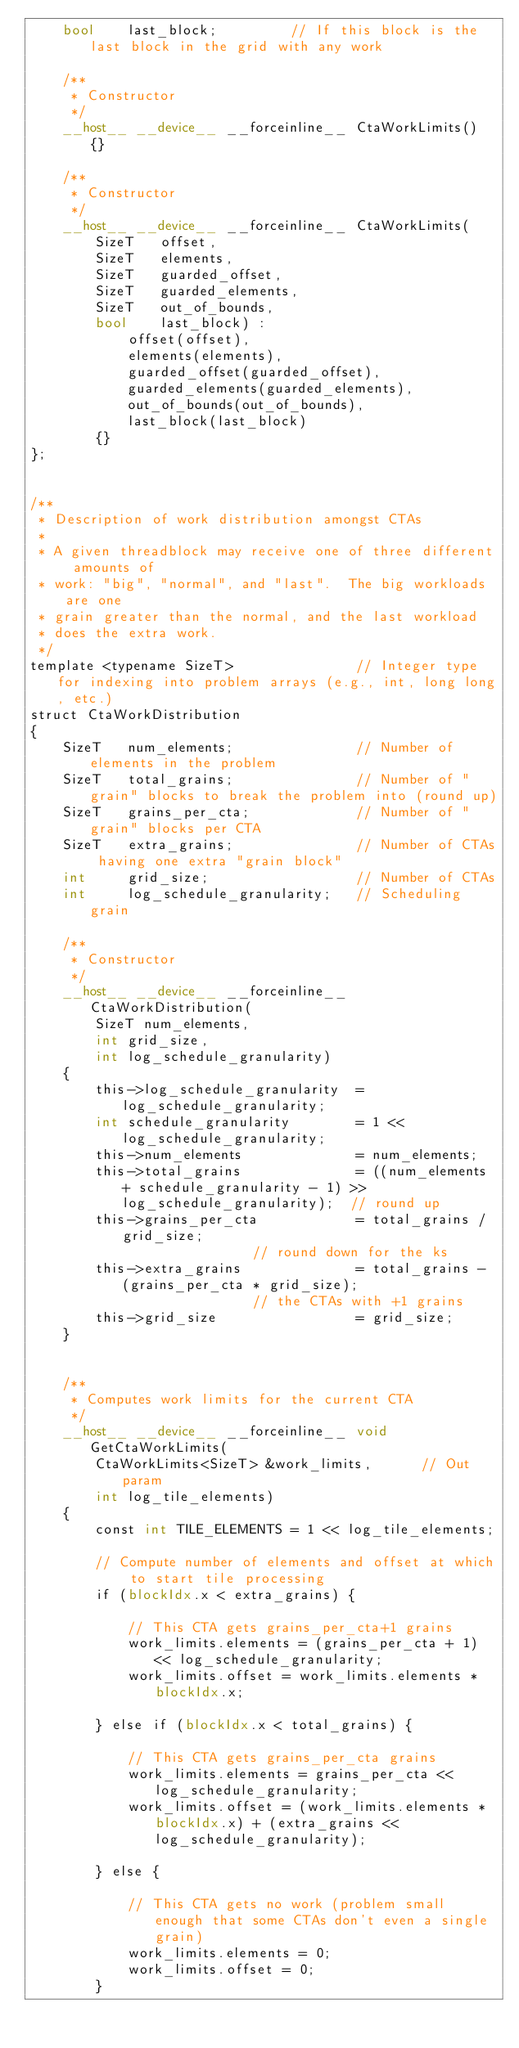<code> <loc_0><loc_0><loc_500><loc_500><_Cuda_>	bool	last_block;			// If this block is the last block in the grid with any work

	/**
	 * Constructor
	 */
	__host__ __device__ __forceinline__ CtaWorkLimits() {}

	/**
	 * Constructor
	 */
	__host__ __device__ __forceinline__ CtaWorkLimits(
		SizeT 	offset,
		SizeT 	elements,
		SizeT 	guarded_offset,
		SizeT 	guarded_elements,
		SizeT 	out_of_bounds,
		bool	last_block) :
			offset(offset),
			elements(elements),
			guarded_offset(guarded_offset),
			guarded_elements(guarded_elements),
			out_of_bounds(out_of_bounds),
			last_block(last_block)
		{}
};


/**
 * Description of work distribution amongst CTAs
 *
 * A given threadblock may receive one of three different amounts of 
 * work: "big", "normal", and "last".  The big workloads are one
 * grain greater than the normal, and the last workload 
 * does the extra work.
 */
template <typename SizeT> 				// Integer type for indexing into problem arrays (e.g., int, long long, etc.)
struct CtaWorkDistribution
{
	SizeT 	num_elements;				// Number of elements in the problem
	SizeT 	total_grains;				// Number of "grain" blocks to break the problem into (round up)
	SizeT 	grains_per_cta;				// Number of "grain" blocks per CTA
	SizeT 	extra_grains;				// Number of CTAs having one extra "grain block"
	int 	grid_size;					// Number of CTAs
	int 	log_schedule_granularity;	// Scheduling grain

	/**
	 * Constructor
	 */
	__host__ __device__ __forceinline__ CtaWorkDistribution(
		SizeT num_elements,
		int grid_size,
		int log_schedule_granularity)
	{
		this->log_schedule_granularity 	= log_schedule_granularity;
		int schedule_granularity 		= 1 << log_schedule_granularity;
		this->num_elements 				= num_elements;
		this->total_grains 				= ((num_elements + schedule_granularity - 1) >> log_schedule_granularity);	// round up
		this->grains_per_cta 			= total_grains / grid_size;													// round down for the ks
		this->extra_grains 				= total_grains - (grains_per_cta * grid_size);								// the CTAs with +1 grains
		this->grid_size 				= grid_size;
	}


	/**
	 * Computes work limits for the current CTA
	 */	
	__host__ __device__ __forceinline__ void GetCtaWorkLimits(
		CtaWorkLimits<SizeT> &work_limits,		// Out param
		int log_tile_elements)
	{
		const int TILE_ELEMENTS = 1 << log_tile_elements;
		
		// Compute number of elements and offset at which to start tile processing
		if (blockIdx.x < extra_grains) {

			// This CTA gets grains_per_cta+1 grains
			work_limits.elements = (grains_per_cta + 1) << log_schedule_granularity;
			work_limits.offset = work_limits.elements * blockIdx.x;

		} else if (blockIdx.x < total_grains) {

			// This CTA gets grains_per_cta grains
			work_limits.elements = grains_per_cta << log_schedule_granularity;
			work_limits.offset = (work_limits.elements * blockIdx.x) + (extra_grains << log_schedule_granularity);

		} else {

			// This CTA gets no work (problem small enough that some CTAs don't even a single grain)
			work_limits.elements = 0;
			work_limits.offset = 0;
		}
</code> 